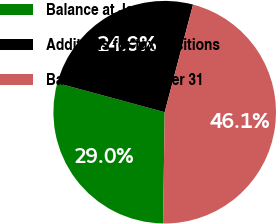<chart> <loc_0><loc_0><loc_500><loc_500><pie_chart><fcel>Balance at January 1<fcel>Additions for tax positions<fcel>Balance at December 31<nl><fcel>28.99%<fcel>24.88%<fcel>46.14%<nl></chart> 